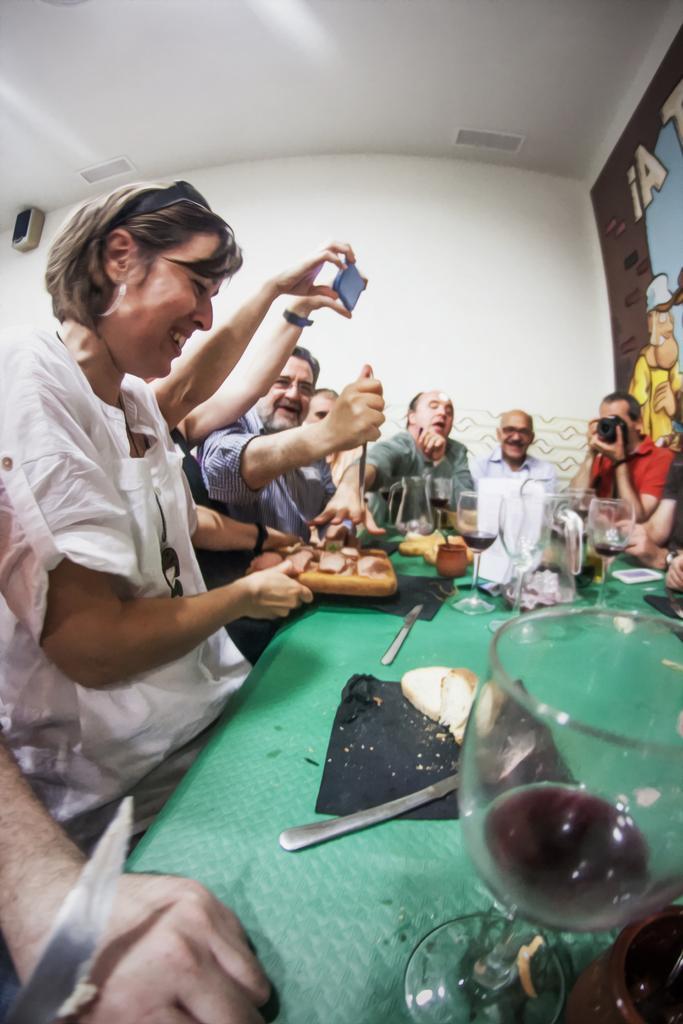How would you summarize this image in a sentence or two? In this picture we can see a group of people sitting and some people are holding the objects. In front of the people, there is a table and on the table, there are glasses, a knife and some other objects. At the top left corner of the image, there is an object attached to a wall. On the right side of the image, there is a painting. 